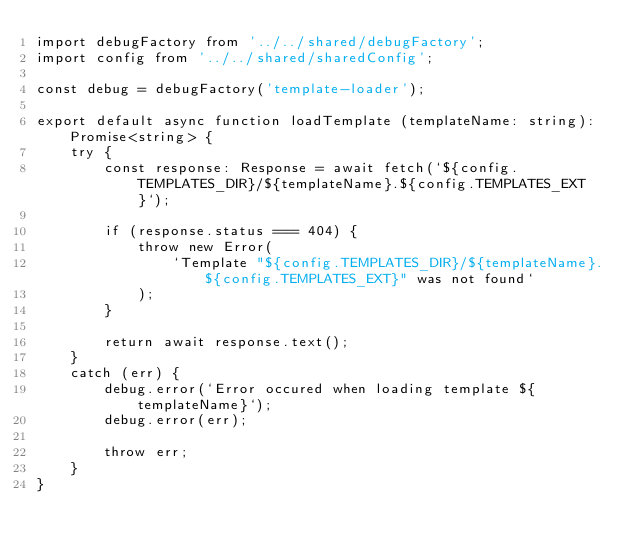Convert code to text. <code><loc_0><loc_0><loc_500><loc_500><_TypeScript_>import debugFactory from '../../shared/debugFactory';
import config from '../../shared/sharedConfig';

const debug = debugFactory('template-loader');

export default async function loadTemplate (templateName: string): Promise<string> {
    try {
        const response: Response = await fetch(`${config.TEMPLATES_DIR}/${templateName}.${config.TEMPLATES_EXT}`);

        if (response.status === 404) {
            throw new Error(
                `Template "${config.TEMPLATES_DIR}/${templateName}.${config.TEMPLATES_EXT}" was not found`
            );
        }

        return await response.text();
    }
    catch (err) {
        debug.error(`Error occured when loading template ${templateName}`);
        debug.error(err);

        throw err;
    }
}
</code> 